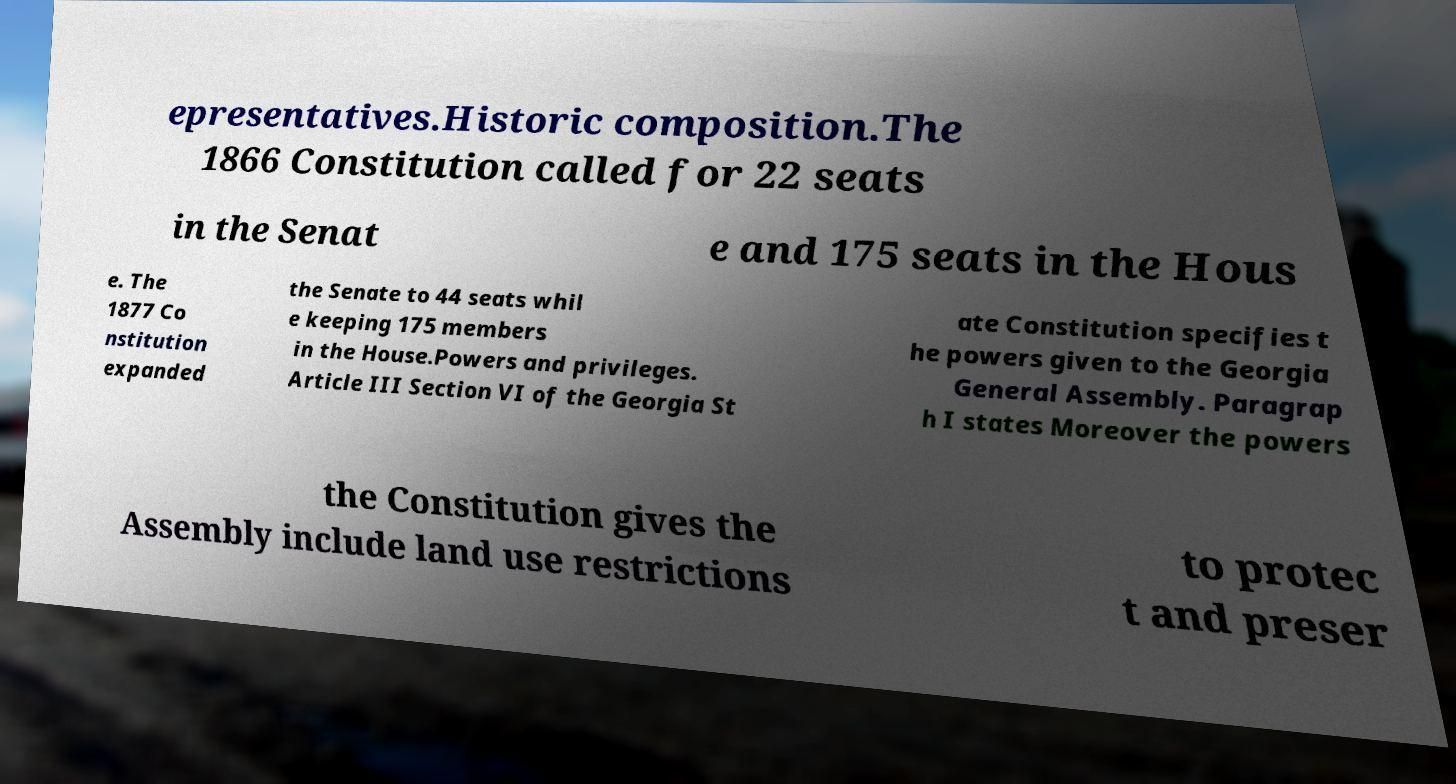I need the written content from this picture converted into text. Can you do that? epresentatives.Historic composition.The 1866 Constitution called for 22 seats in the Senat e and 175 seats in the Hous e. The 1877 Co nstitution expanded the Senate to 44 seats whil e keeping 175 members in the House.Powers and privileges. Article III Section VI of the Georgia St ate Constitution specifies t he powers given to the Georgia General Assembly. Paragrap h I states Moreover the powers the Constitution gives the Assembly include land use restrictions to protec t and preser 